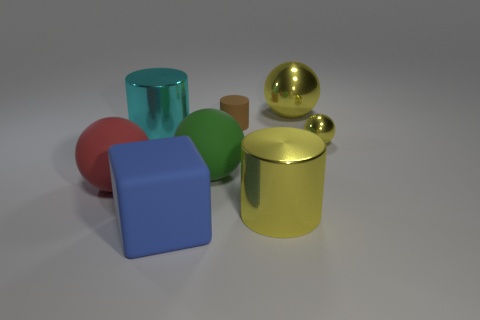Subtract all brown cylinders. Subtract all gray spheres. How many cylinders are left? 2 Subtract all cyan cylinders. How many yellow blocks are left? 0 Add 4 big cyans. How many small yellows exist? 0 Subtract all small metallic spheres. Subtract all large gray things. How many objects are left? 7 Add 5 small things. How many small things are left? 7 Add 6 big matte things. How many big matte things exist? 9 Add 2 big yellow things. How many objects exist? 10 Subtract all red spheres. How many spheres are left? 3 Subtract all big cylinders. How many cylinders are left? 1 Subtract 0 purple spheres. How many objects are left? 8 